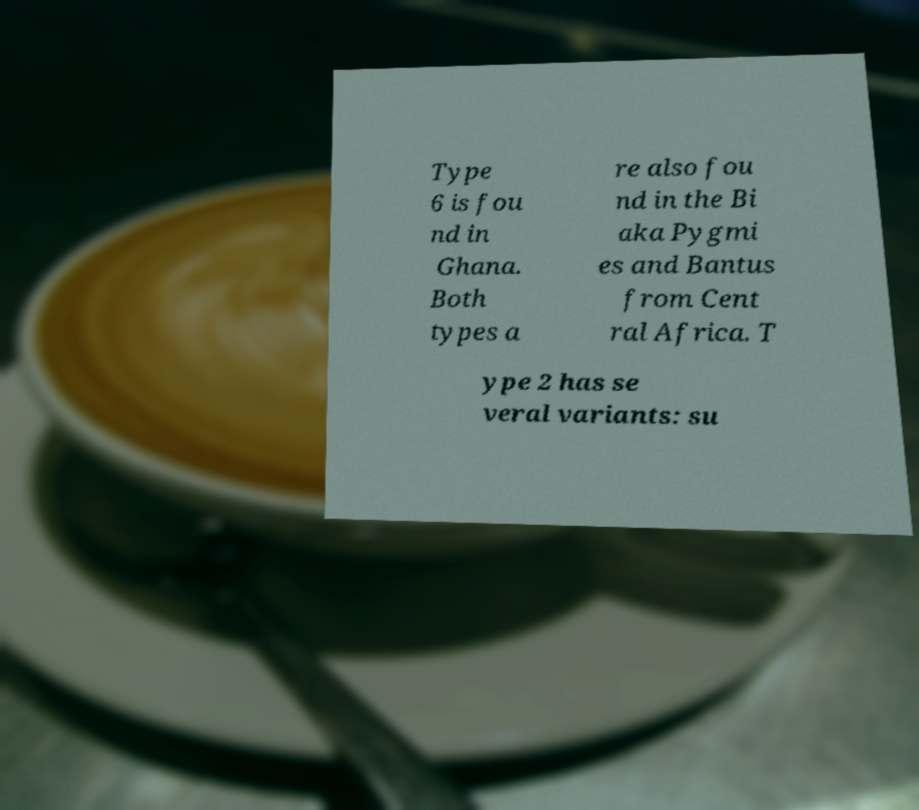Can you read and provide the text displayed in the image?This photo seems to have some interesting text. Can you extract and type it out for me? Type 6 is fou nd in Ghana. Both types a re also fou nd in the Bi aka Pygmi es and Bantus from Cent ral Africa. T ype 2 has se veral variants: su 